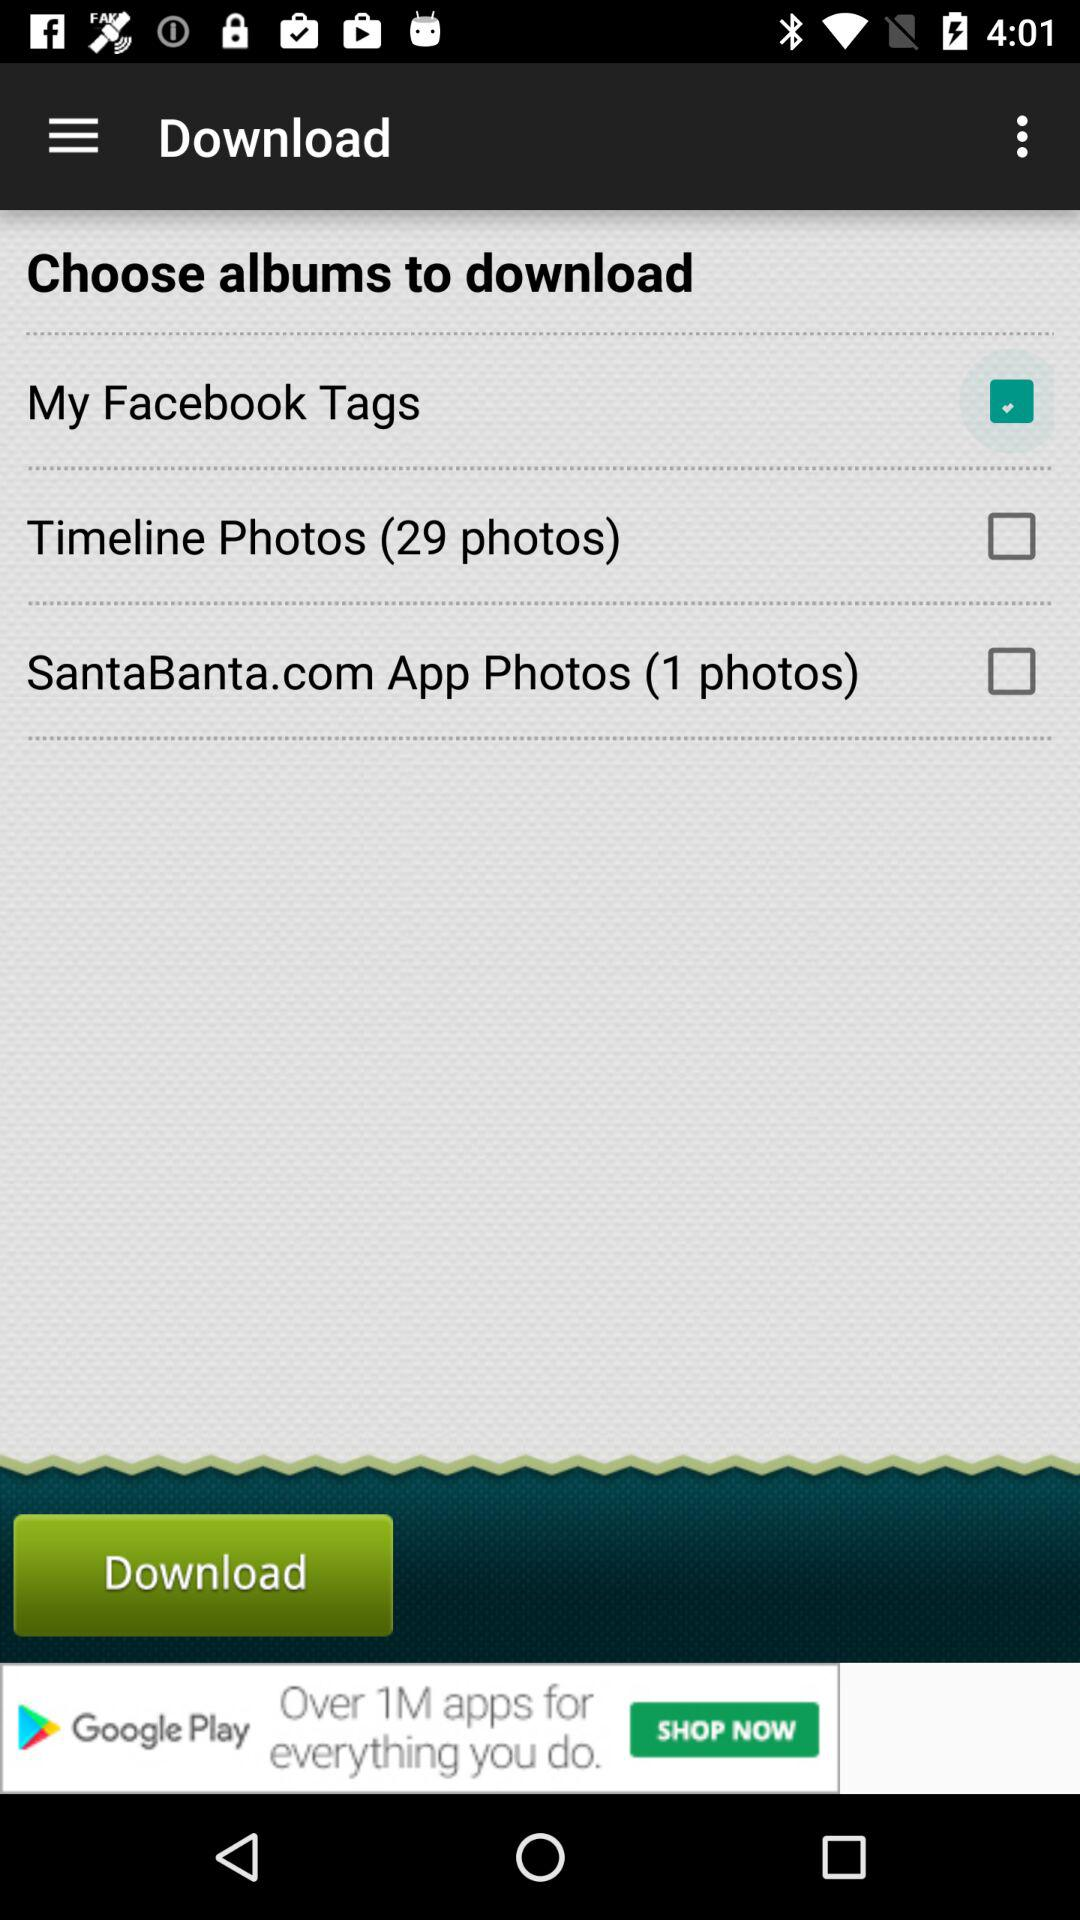How many Facebook tags are there?
When the provided information is insufficient, respond with <no answer>. <no answer> 